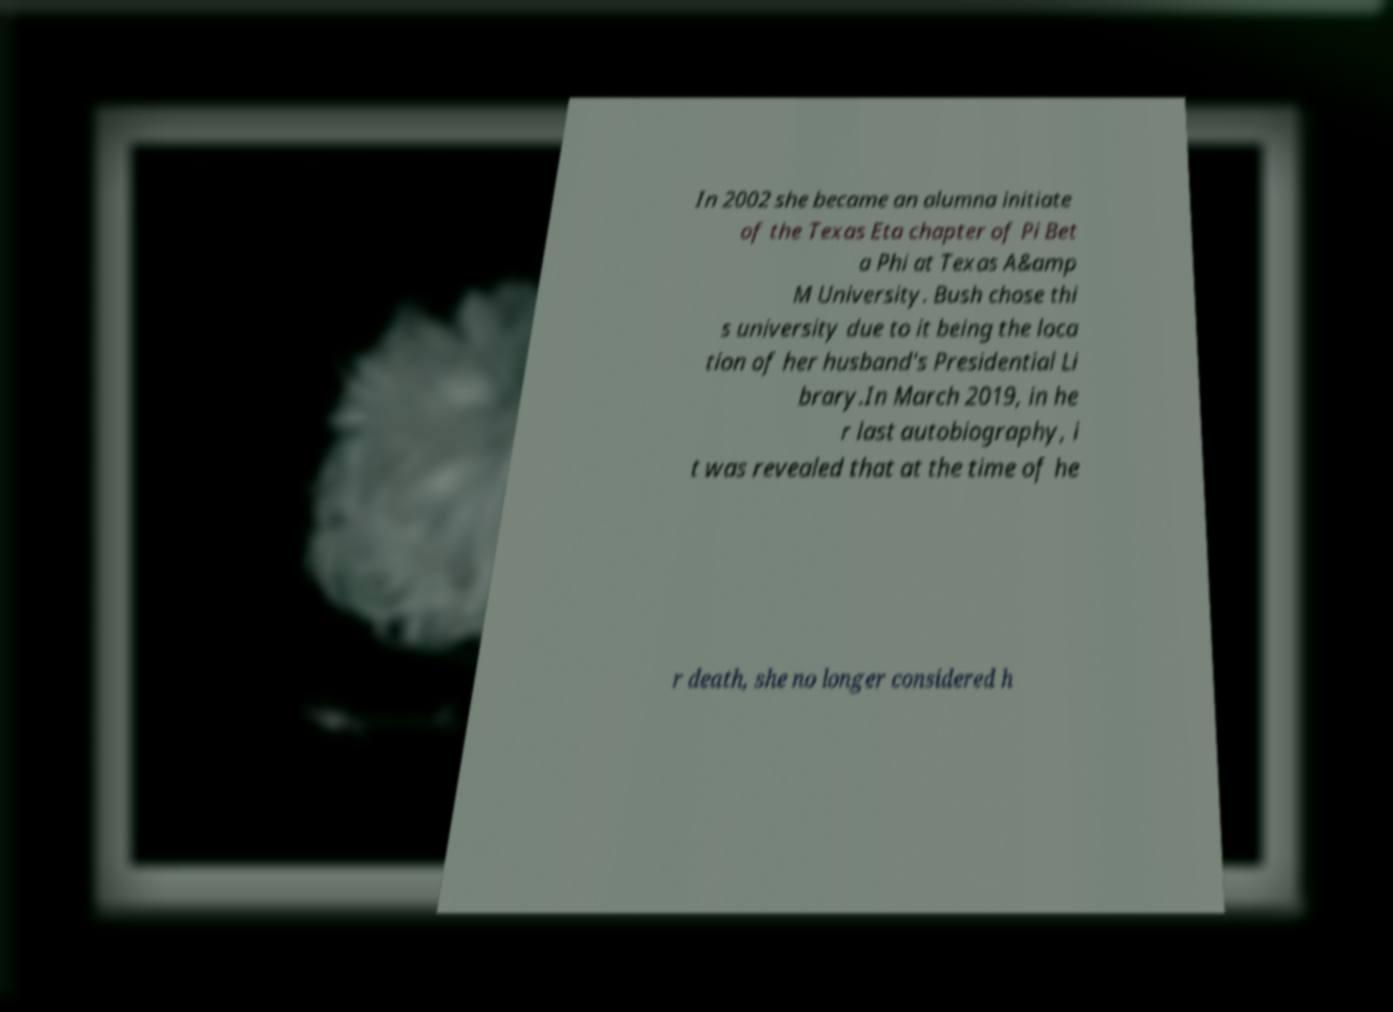Can you accurately transcribe the text from the provided image for me? In 2002 she became an alumna initiate of the Texas Eta chapter of Pi Bet a Phi at Texas A&amp M University. Bush chose thi s university due to it being the loca tion of her husband's Presidential Li brary.In March 2019, in he r last autobiography, i t was revealed that at the time of he r death, she no longer considered h 